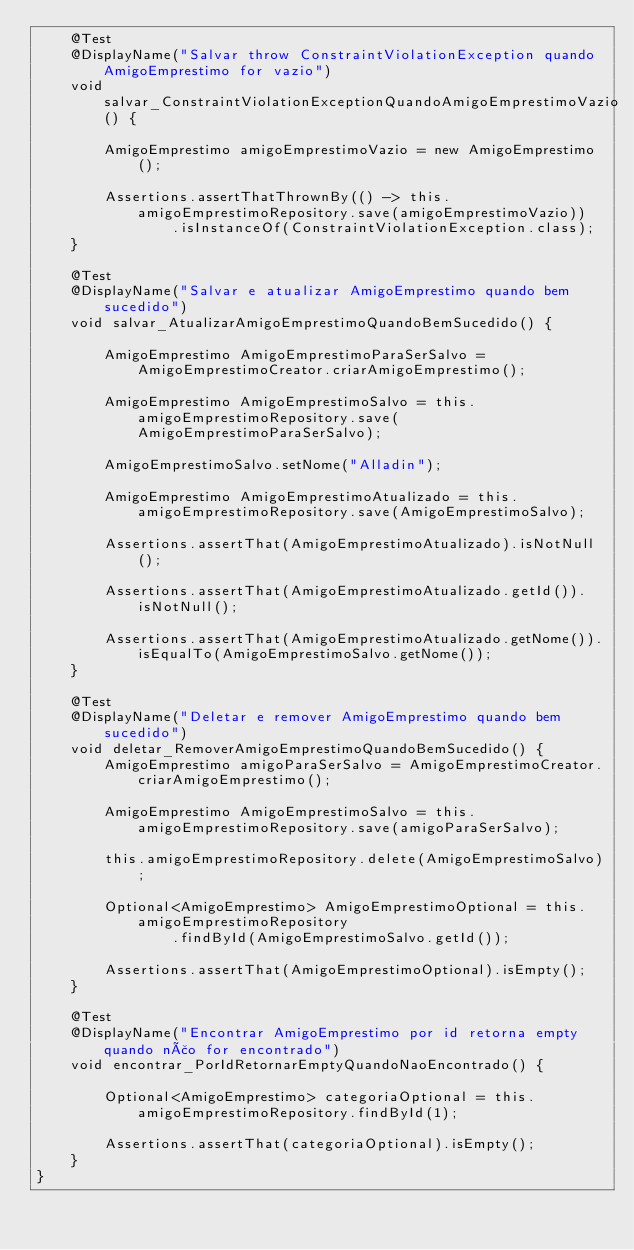Convert code to text. <code><loc_0><loc_0><loc_500><loc_500><_Java_>    @Test
    @DisplayName("Salvar throw ConstraintViolationException quando AmigoEmprestimo for vazio")
    void salvar_ConstraintViolationExceptionQuandoAmigoEmprestimoVazio() {

        AmigoEmprestimo amigoEmprestimoVazio = new AmigoEmprestimo();

        Assertions.assertThatThrownBy(() -> this.amigoEmprestimoRepository.save(amigoEmprestimoVazio))
                .isInstanceOf(ConstraintViolationException.class);
    }

    @Test
    @DisplayName("Salvar e atualizar AmigoEmprestimo quando bem sucedido")
    void salvar_AtualizarAmigoEmprestimoQuandoBemSucedido() {

        AmigoEmprestimo AmigoEmprestimoParaSerSalvo = AmigoEmprestimoCreator.criarAmigoEmprestimo();

        AmigoEmprestimo AmigoEmprestimoSalvo = this.amigoEmprestimoRepository.save(AmigoEmprestimoParaSerSalvo);

        AmigoEmprestimoSalvo.setNome("Alladin");

        AmigoEmprestimo AmigoEmprestimoAtualizado = this.amigoEmprestimoRepository.save(AmigoEmprestimoSalvo);

        Assertions.assertThat(AmigoEmprestimoAtualizado).isNotNull();

        Assertions.assertThat(AmigoEmprestimoAtualizado.getId()).isNotNull();

        Assertions.assertThat(AmigoEmprestimoAtualizado.getNome()).isEqualTo(AmigoEmprestimoSalvo.getNome());
    }

    @Test
    @DisplayName("Deletar e remover AmigoEmprestimo quando bem sucedido")
    void deletar_RemoverAmigoEmprestimoQuandoBemSucedido() {
        AmigoEmprestimo amigoParaSerSalvo = AmigoEmprestimoCreator.criarAmigoEmprestimo();

        AmigoEmprestimo AmigoEmprestimoSalvo = this.amigoEmprestimoRepository.save(amigoParaSerSalvo);

        this.amigoEmprestimoRepository.delete(AmigoEmprestimoSalvo);

        Optional<AmigoEmprestimo> AmigoEmprestimoOptional = this.amigoEmprestimoRepository
                .findById(AmigoEmprestimoSalvo.getId());

        Assertions.assertThat(AmigoEmprestimoOptional).isEmpty();
    }

    @Test
    @DisplayName("Encontrar AmigoEmprestimo por id retorna empty quando não for encontrado")
    void encontrar_PorIdRetornarEmptyQuandoNaoEncontrado() {

        Optional<AmigoEmprestimo> categoriaOptional = this.amigoEmprestimoRepository.findById(1);

        Assertions.assertThat(categoriaOptional).isEmpty();
    }
}
</code> 